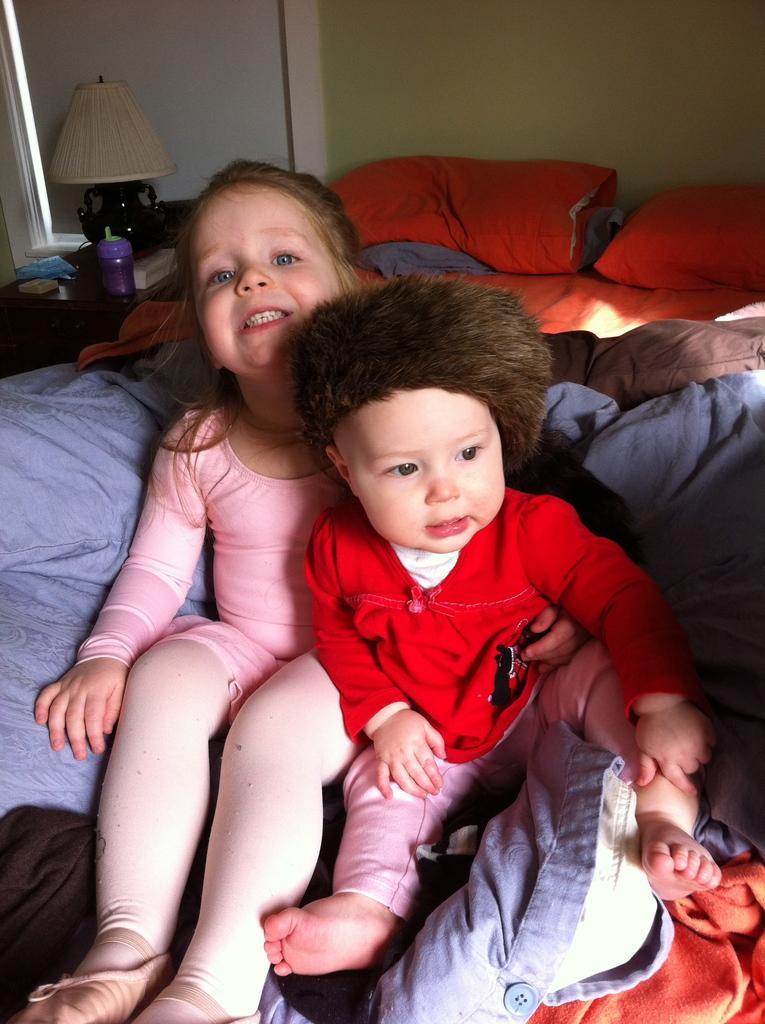How would you summarize this image in a sentence or two? In this image we can see the kids sitting on the bed. We can also see the blankets, pillows and also the wall in the background. We can see a lamp, bottle and some other objects on the table. 